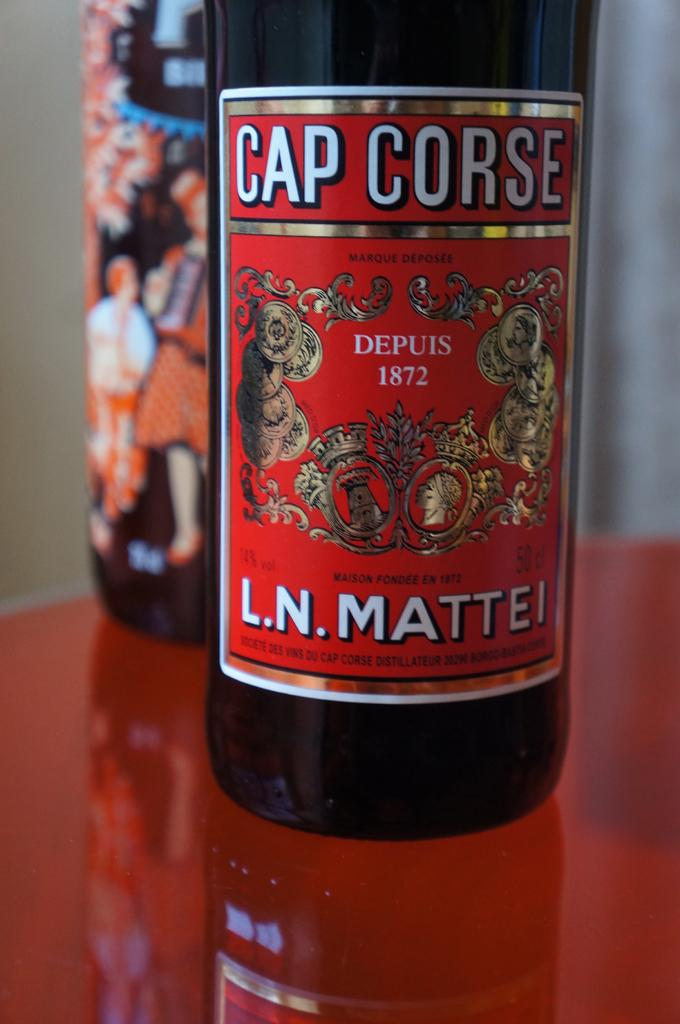<image>
Create a compact narrative representing the image presented. red, white and gold labeled bottle of cap corse 